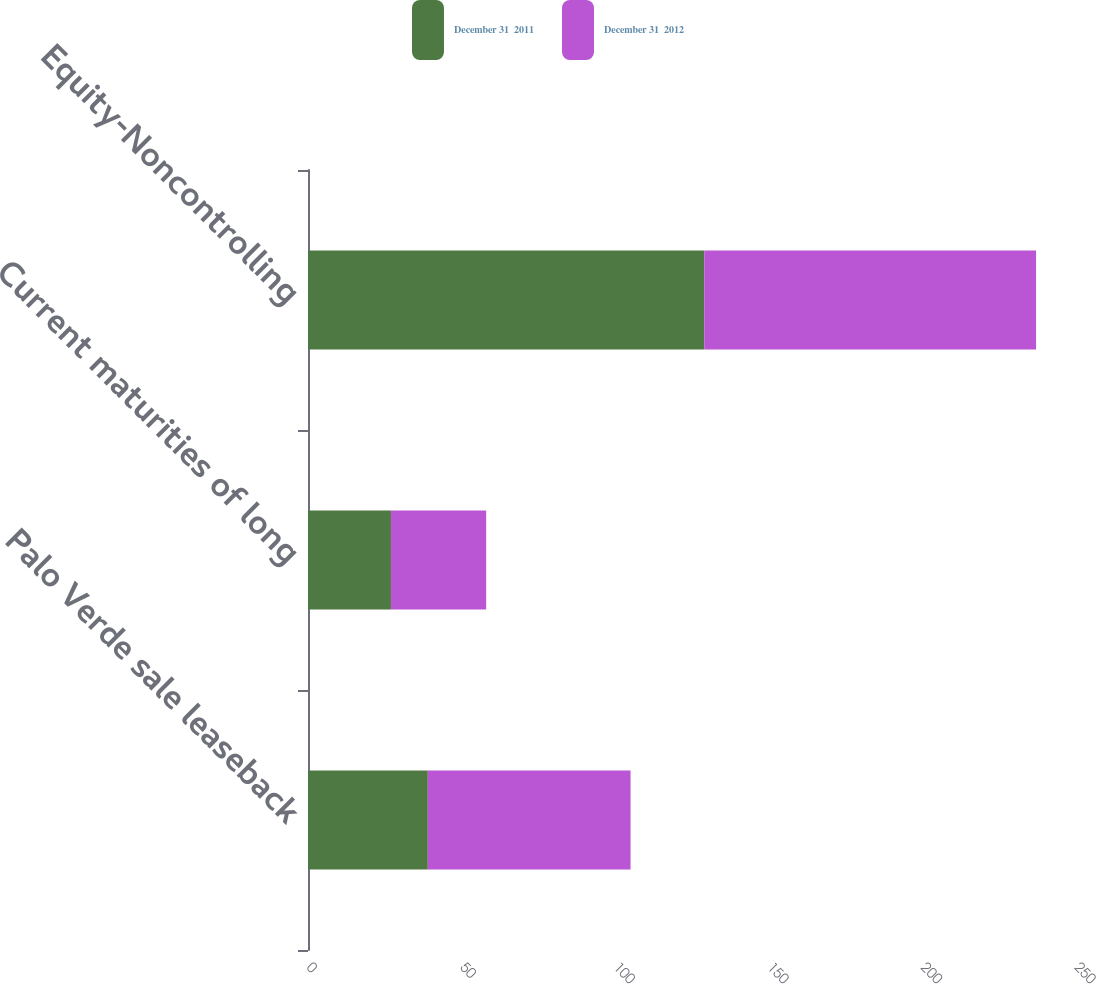Convert chart. <chart><loc_0><loc_0><loc_500><loc_500><stacked_bar_chart><ecel><fcel>Palo Verde sale leaseback<fcel>Current maturities of long<fcel>Equity-Noncontrolling<nl><fcel>December 31  2011<fcel>39<fcel>27<fcel>129<nl><fcel>December 31  2012<fcel>66<fcel>31<fcel>108<nl></chart> 